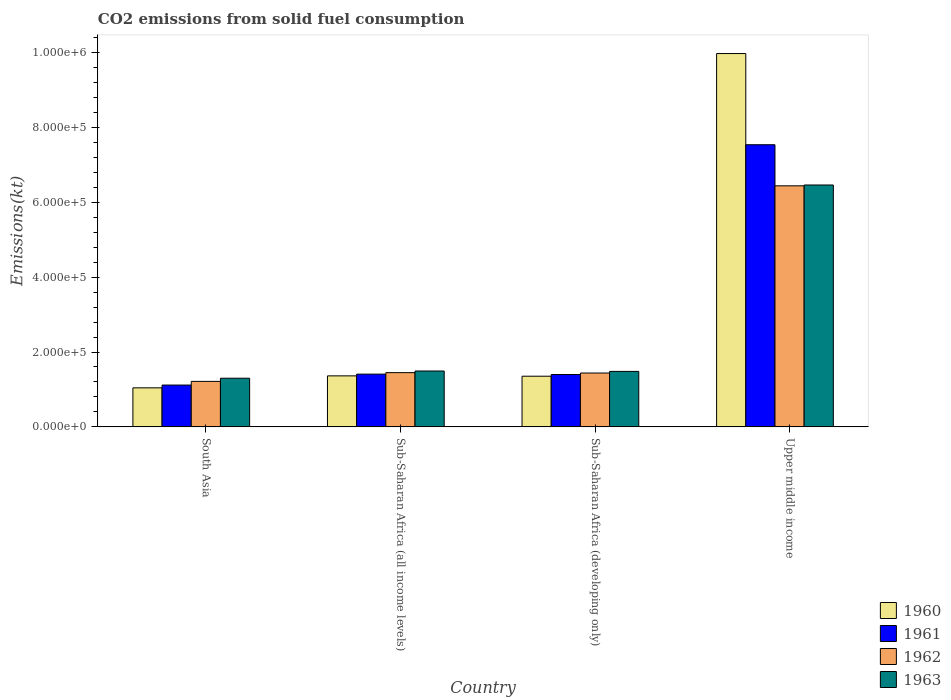Are the number of bars per tick equal to the number of legend labels?
Your answer should be compact. Yes. Are the number of bars on each tick of the X-axis equal?
Ensure brevity in your answer.  Yes. What is the label of the 3rd group of bars from the left?
Your response must be concise. Sub-Saharan Africa (developing only). What is the amount of CO2 emitted in 1962 in Sub-Saharan Africa (all income levels)?
Provide a short and direct response. 1.45e+05. Across all countries, what is the maximum amount of CO2 emitted in 1962?
Ensure brevity in your answer.  6.44e+05. Across all countries, what is the minimum amount of CO2 emitted in 1963?
Provide a short and direct response. 1.30e+05. In which country was the amount of CO2 emitted in 1960 maximum?
Make the answer very short. Upper middle income. In which country was the amount of CO2 emitted in 1962 minimum?
Your answer should be very brief. South Asia. What is the total amount of CO2 emitted in 1962 in the graph?
Your answer should be very brief. 1.05e+06. What is the difference between the amount of CO2 emitted in 1961 in South Asia and that in Sub-Saharan Africa (developing only)?
Offer a very short reply. -2.82e+04. What is the difference between the amount of CO2 emitted in 1962 in Upper middle income and the amount of CO2 emitted in 1960 in Sub-Saharan Africa (developing only)?
Make the answer very short. 5.09e+05. What is the average amount of CO2 emitted in 1963 per country?
Your answer should be very brief. 2.68e+05. What is the difference between the amount of CO2 emitted of/in 1960 and amount of CO2 emitted of/in 1962 in Sub-Saharan Africa (developing only)?
Keep it short and to the point. -8539.18. What is the ratio of the amount of CO2 emitted in 1960 in South Asia to that in Sub-Saharan Africa (developing only)?
Provide a short and direct response. 0.77. Is the amount of CO2 emitted in 1962 in Sub-Saharan Africa (all income levels) less than that in Sub-Saharan Africa (developing only)?
Give a very brief answer. No. What is the difference between the highest and the second highest amount of CO2 emitted in 1960?
Ensure brevity in your answer.  8.61e+05. What is the difference between the highest and the lowest amount of CO2 emitted in 1960?
Make the answer very short. 8.93e+05. Is the sum of the amount of CO2 emitted in 1963 in South Asia and Sub-Saharan Africa (all income levels) greater than the maximum amount of CO2 emitted in 1961 across all countries?
Your answer should be very brief. No. Is it the case that in every country, the sum of the amount of CO2 emitted in 1961 and amount of CO2 emitted in 1963 is greater than the sum of amount of CO2 emitted in 1962 and amount of CO2 emitted in 1960?
Your answer should be very brief. No. Is it the case that in every country, the sum of the amount of CO2 emitted in 1961 and amount of CO2 emitted in 1960 is greater than the amount of CO2 emitted in 1963?
Give a very brief answer. Yes. Are the values on the major ticks of Y-axis written in scientific E-notation?
Your response must be concise. Yes. Does the graph contain grids?
Offer a very short reply. No. Where does the legend appear in the graph?
Ensure brevity in your answer.  Bottom right. How are the legend labels stacked?
Offer a terse response. Vertical. What is the title of the graph?
Offer a very short reply. CO2 emissions from solid fuel consumption. What is the label or title of the Y-axis?
Offer a very short reply. Emissions(kt). What is the Emissions(kt) of 1960 in South Asia?
Provide a short and direct response. 1.04e+05. What is the Emissions(kt) of 1961 in South Asia?
Provide a short and direct response. 1.12e+05. What is the Emissions(kt) in 1962 in South Asia?
Ensure brevity in your answer.  1.22e+05. What is the Emissions(kt) in 1963 in South Asia?
Provide a succinct answer. 1.30e+05. What is the Emissions(kt) of 1960 in Sub-Saharan Africa (all income levels)?
Ensure brevity in your answer.  1.36e+05. What is the Emissions(kt) in 1961 in Sub-Saharan Africa (all income levels)?
Your answer should be compact. 1.41e+05. What is the Emissions(kt) in 1962 in Sub-Saharan Africa (all income levels)?
Offer a very short reply. 1.45e+05. What is the Emissions(kt) of 1963 in Sub-Saharan Africa (all income levels)?
Give a very brief answer. 1.49e+05. What is the Emissions(kt) in 1960 in Sub-Saharan Africa (developing only)?
Ensure brevity in your answer.  1.35e+05. What is the Emissions(kt) of 1961 in Sub-Saharan Africa (developing only)?
Ensure brevity in your answer.  1.40e+05. What is the Emissions(kt) of 1962 in Sub-Saharan Africa (developing only)?
Provide a succinct answer. 1.44e+05. What is the Emissions(kt) in 1963 in Sub-Saharan Africa (developing only)?
Your response must be concise. 1.48e+05. What is the Emissions(kt) of 1960 in Upper middle income?
Your answer should be compact. 9.97e+05. What is the Emissions(kt) of 1961 in Upper middle income?
Offer a terse response. 7.54e+05. What is the Emissions(kt) of 1962 in Upper middle income?
Give a very brief answer. 6.44e+05. What is the Emissions(kt) in 1963 in Upper middle income?
Provide a short and direct response. 6.46e+05. Across all countries, what is the maximum Emissions(kt) of 1960?
Ensure brevity in your answer.  9.97e+05. Across all countries, what is the maximum Emissions(kt) in 1961?
Provide a short and direct response. 7.54e+05. Across all countries, what is the maximum Emissions(kt) of 1962?
Provide a short and direct response. 6.44e+05. Across all countries, what is the maximum Emissions(kt) in 1963?
Keep it short and to the point. 6.46e+05. Across all countries, what is the minimum Emissions(kt) in 1960?
Make the answer very short. 1.04e+05. Across all countries, what is the minimum Emissions(kt) in 1961?
Provide a succinct answer. 1.12e+05. Across all countries, what is the minimum Emissions(kt) of 1962?
Offer a very short reply. 1.22e+05. Across all countries, what is the minimum Emissions(kt) in 1963?
Keep it short and to the point. 1.30e+05. What is the total Emissions(kt) of 1960 in the graph?
Your answer should be very brief. 1.37e+06. What is the total Emissions(kt) in 1961 in the graph?
Provide a succinct answer. 1.15e+06. What is the total Emissions(kt) in 1962 in the graph?
Provide a succinct answer. 1.05e+06. What is the total Emissions(kt) of 1963 in the graph?
Offer a terse response. 1.07e+06. What is the difference between the Emissions(kt) in 1960 in South Asia and that in Sub-Saharan Africa (all income levels)?
Ensure brevity in your answer.  -3.20e+04. What is the difference between the Emissions(kt) of 1961 in South Asia and that in Sub-Saharan Africa (all income levels)?
Offer a very short reply. -2.92e+04. What is the difference between the Emissions(kt) in 1962 in South Asia and that in Sub-Saharan Africa (all income levels)?
Your answer should be very brief. -2.33e+04. What is the difference between the Emissions(kt) in 1963 in South Asia and that in Sub-Saharan Africa (all income levels)?
Give a very brief answer. -1.93e+04. What is the difference between the Emissions(kt) in 1960 in South Asia and that in Sub-Saharan Africa (developing only)?
Give a very brief answer. -3.10e+04. What is the difference between the Emissions(kt) of 1961 in South Asia and that in Sub-Saharan Africa (developing only)?
Make the answer very short. -2.82e+04. What is the difference between the Emissions(kt) in 1962 in South Asia and that in Sub-Saharan Africa (developing only)?
Make the answer very short. -2.23e+04. What is the difference between the Emissions(kt) of 1963 in South Asia and that in Sub-Saharan Africa (developing only)?
Your answer should be compact. -1.82e+04. What is the difference between the Emissions(kt) in 1960 in South Asia and that in Upper middle income?
Make the answer very short. -8.93e+05. What is the difference between the Emissions(kt) in 1961 in South Asia and that in Upper middle income?
Your answer should be very brief. -6.42e+05. What is the difference between the Emissions(kt) of 1962 in South Asia and that in Upper middle income?
Your response must be concise. -5.22e+05. What is the difference between the Emissions(kt) in 1963 in South Asia and that in Upper middle income?
Give a very brief answer. -5.16e+05. What is the difference between the Emissions(kt) of 1960 in Sub-Saharan Africa (all income levels) and that in Sub-Saharan Africa (developing only)?
Provide a short and direct response. 947.7. What is the difference between the Emissions(kt) of 1961 in Sub-Saharan Africa (all income levels) and that in Sub-Saharan Africa (developing only)?
Your response must be concise. 979.79. What is the difference between the Emissions(kt) in 1962 in Sub-Saharan Africa (all income levels) and that in Sub-Saharan Africa (developing only)?
Give a very brief answer. 1007.5. What is the difference between the Emissions(kt) in 1963 in Sub-Saharan Africa (all income levels) and that in Sub-Saharan Africa (developing only)?
Your answer should be very brief. 1037.94. What is the difference between the Emissions(kt) of 1960 in Sub-Saharan Africa (all income levels) and that in Upper middle income?
Offer a terse response. -8.61e+05. What is the difference between the Emissions(kt) of 1961 in Sub-Saharan Africa (all income levels) and that in Upper middle income?
Make the answer very short. -6.13e+05. What is the difference between the Emissions(kt) in 1962 in Sub-Saharan Africa (all income levels) and that in Upper middle income?
Your answer should be very brief. -4.99e+05. What is the difference between the Emissions(kt) of 1963 in Sub-Saharan Africa (all income levels) and that in Upper middle income?
Offer a very short reply. -4.97e+05. What is the difference between the Emissions(kt) in 1960 in Sub-Saharan Africa (developing only) and that in Upper middle income?
Provide a short and direct response. -8.62e+05. What is the difference between the Emissions(kt) of 1961 in Sub-Saharan Africa (developing only) and that in Upper middle income?
Give a very brief answer. -6.14e+05. What is the difference between the Emissions(kt) in 1962 in Sub-Saharan Africa (developing only) and that in Upper middle income?
Your response must be concise. -5.00e+05. What is the difference between the Emissions(kt) of 1963 in Sub-Saharan Africa (developing only) and that in Upper middle income?
Offer a terse response. -4.98e+05. What is the difference between the Emissions(kt) of 1960 in South Asia and the Emissions(kt) of 1961 in Sub-Saharan Africa (all income levels)?
Your response must be concise. -3.66e+04. What is the difference between the Emissions(kt) in 1960 in South Asia and the Emissions(kt) in 1962 in Sub-Saharan Africa (all income levels)?
Provide a succinct answer. -4.06e+04. What is the difference between the Emissions(kt) of 1960 in South Asia and the Emissions(kt) of 1963 in Sub-Saharan Africa (all income levels)?
Give a very brief answer. -4.49e+04. What is the difference between the Emissions(kt) of 1961 in South Asia and the Emissions(kt) of 1962 in Sub-Saharan Africa (all income levels)?
Give a very brief answer. -3.31e+04. What is the difference between the Emissions(kt) of 1961 in South Asia and the Emissions(kt) of 1963 in Sub-Saharan Africa (all income levels)?
Your answer should be very brief. -3.75e+04. What is the difference between the Emissions(kt) in 1962 in South Asia and the Emissions(kt) in 1963 in Sub-Saharan Africa (all income levels)?
Offer a terse response. -2.77e+04. What is the difference between the Emissions(kt) in 1960 in South Asia and the Emissions(kt) in 1961 in Sub-Saharan Africa (developing only)?
Give a very brief answer. -3.56e+04. What is the difference between the Emissions(kt) in 1960 in South Asia and the Emissions(kt) in 1962 in Sub-Saharan Africa (developing only)?
Your answer should be compact. -3.96e+04. What is the difference between the Emissions(kt) of 1960 in South Asia and the Emissions(kt) of 1963 in Sub-Saharan Africa (developing only)?
Offer a very short reply. -4.39e+04. What is the difference between the Emissions(kt) in 1961 in South Asia and the Emissions(kt) in 1962 in Sub-Saharan Africa (developing only)?
Keep it short and to the point. -3.21e+04. What is the difference between the Emissions(kt) of 1961 in South Asia and the Emissions(kt) of 1963 in Sub-Saharan Africa (developing only)?
Provide a succinct answer. -3.65e+04. What is the difference between the Emissions(kt) in 1962 in South Asia and the Emissions(kt) in 1963 in Sub-Saharan Africa (developing only)?
Your answer should be compact. -2.67e+04. What is the difference between the Emissions(kt) of 1960 in South Asia and the Emissions(kt) of 1961 in Upper middle income?
Keep it short and to the point. -6.49e+05. What is the difference between the Emissions(kt) in 1960 in South Asia and the Emissions(kt) in 1962 in Upper middle income?
Keep it short and to the point. -5.40e+05. What is the difference between the Emissions(kt) in 1960 in South Asia and the Emissions(kt) in 1963 in Upper middle income?
Ensure brevity in your answer.  -5.42e+05. What is the difference between the Emissions(kt) in 1961 in South Asia and the Emissions(kt) in 1962 in Upper middle income?
Provide a succinct answer. -5.32e+05. What is the difference between the Emissions(kt) in 1961 in South Asia and the Emissions(kt) in 1963 in Upper middle income?
Provide a short and direct response. -5.34e+05. What is the difference between the Emissions(kt) in 1962 in South Asia and the Emissions(kt) in 1963 in Upper middle income?
Offer a very short reply. -5.25e+05. What is the difference between the Emissions(kt) in 1960 in Sub-Saharan Africa (all income levels) and the Emissions(kt) in 1961 in Sub-Saharan Africa (developing only)?
Make the answer very short. -3634.8. What is the difference between the Emissions(kt) in 1960 in Sub-Saharan Africa (all income levels) and the Emissions(kt) in 1962 in Sub-Saharan Africa (developing only)?
Keep it short and to the point. -7591.49. What is the difference between the Emissions(kt) in 1960 in Sub-Saharan Africa (all income levels) and the Emissions(kt) in 1963 in Sub-Saharan Africa (developing only)?
Your answer should be very brief. -1.19e+04. What is the difference between the Emissions(kt) of 1961 in Sub-Saharan Africa (all income levels) and the Emissions(kt) of 1962 in Sub-Saharan Africa (developing only)?
Ensure brevity in your answer.  -2976.9. What is the difference between the Emissions(kt) in 1961 in Sub-Saharan Africa (all income levels) and the Emissions(kt) in 1963 in Sub-Saharan Africa (developing only)?
Provide a short and direct response. -7322.24. What is the difference between the Emissions(kt) in 1962 in Sub-Saharan Africa (all income levels) and the Emissions(kt) in 1963 in Sub-Saharan Africa (developing only)?
Offer a very short reply. -3337.84. What is the difference between the Emissions(kt) of 1960 in Sub-Saharan Africa (all income levels) and the Emissions(kt) of 1961 in Upper middle income?
Ensure brevity in your answer.  -6.17e+05. What is the difference between the Emissions(kt) of 1960 in Sub-Saharan Africa (all income levels) and the Emissions(kt) of 1962 in Upper middle income?
Provide a succinct answer. -5.08e+05. What is the difference between the Emissions(kt) of 1960 in Sub-Saharan Africa (all income levels) and the Emissions(kt) of 1963 in Upper middle income?
Your answer should be compact. -5.10e+05. What is the difference between the Emissions(kt) of 1961 in Sub-Saharan Africa (all income levels) and the Emissions(kt) of 1962 in Upper middle income?
Ensure brevity in your answer.  -5.03e+05. What is the difference between the Emissions(kt) in 1961 in Sub-Saharan Africa (all income levels) and the Emissions(kt) in 1963 in Upper middle income?
Give a very brief answer. -5.05e+05. What is the difference between the Emissions(kt) of 1962 in Sub-Saharan Africa (all income levels) and the Emissions(kt) of 1963 in Upper middle income?
Your response must be concise. -5.01e+05. What is the difference between the Emissions(kt) of 1960 in Sub-Saharan Africa (developing only) and the Emissions(kt) of 1961 in Upper middle income?
Provide a succinct answer. -6.18e+05. What is the difference between the Emissions(kt) in 1960 in Sub-Saharan Africa (developing only) and the Emissions(kt) in 1962 in Upper middle income?
Offer a terse response. -5.09e+05. What is the difference between the Emissions(kt) of 1960 in Sub-Saharan Africa (developing only) and the Emissions(kt) of 1963 in Upper middle income?
Offer a very short reply. -5.11e+05. What is the difference between the Emissions(kt) in 1961 in Sub-Saharan Africa (developing only) and the Emissions(kt) in 1962 in Upper middle income?
Your answer should be very brief. -5.04e+05. What is the difference between the Emissions(kt) in 1961 in Sub-Saharan Africa (developing only) and the Emissions(kt) in 1963 in Upper middle income?
Keep it short and to the point. -5.06e+05. What is the difference between the Emissions(kt) in 1962 in Sub-Saharan Africa (developing only) and the Emissions(kt) in 1963 in Upper middle income?
Your response must be concise. -5.02e+05. What is the average Emissions(kt) in 1960 per country?
Ensure brevity in your answer.  3.43e+05. What is the average Emissions(kt) of 1961 per country?
Provide a succinct answer. 2.87e+05. What is the average Emissions(kt) in 1962 per country?
Your response must be concise. 2.64e+05. What is the average Emissions(kt) in 1963 per country?
Your response must be concise. 2.68e+05. What is the difference between the Emissions(kt) in 1960 and Emissions(kt) in 1961 in South Asia?
Your answer should be compact. -7419.38. What is the difference between the Emissions(kt) of 1960 and Emissions(kt) of 1962 in South Asia?
Provide a succinct answer. -1.72e+04. What is the difference between the Emissions(kt) in 1960 and Emissions(kt) in 1963 in South Asia?
Your answer should be very brief. -2.57e+04. What is the difference between the Emissions(kt) in 1961 and Emissions(kt) in 1962 in South Asia?
Ensure brevity in your answer.  -9815.22. What is the difference between the Emissions(kt) in 1961 and Emissions(kt) in 1963 in South Asia?
Provide a succinct answer. -1.82e+04. What is the difference between the Emissions(kt) in 1962 and Emissions(kt) in 1963 in South Asia?
Provide a succinct answer. -8416.72. What is the difference between the Emissions(kt) in 1960 and Emissions(kt) in 1961 in Sub-Saharan Africa (all income levels)?
Ensure brevity in your answer.  -4614.59. What is the difference between the Emissions(kt) of 1960 and Emissions(kt) of 1962 in Sub-Saharan Africa (all income levels)?
Your answer should be compact. -8598.99. What is the difference between the Emissions(kt) in 1960 and Emissions(kt) in 1963 in Sub-Saharan Africa (all income levels)?
Offer a terse response. -1.30e+04. What is the difference between the Emissions(kt) of 1961 and Emissions(kt) of 1962 in Sub-Saharan Africa (all income levels)?
Your response must be concise. -3984.4. What is the difference between the Emissions(kt) in 1961 and Emissions(kt) in 1963 in Sub-Saharan Africa (all income levels)?
Offer a terse response. -8360.18. What is the difference between the Emissions(kt) in 1962 and Emissions(kt) in 1963 in Sub-Saharan Africa (all income levels)?
Make the answer very short. -4375.77. What is the difference between the Emissions(kt) of 1960 and Emissions(kt) of 1961 in Sub-Saharan Africa (developing only)?
Your answer should be compact. -4582.5. What is the difference between the Emissions(kt) in 1960 and Emissions(kt) in 1962 in Sub-Saharan Africa (developing only)?
Give a very brief answer. -8539.18. What is the difference between the Emissions(kt) of 1960 and Emissions(kt) of 1963 in Sub-Saharan Africa (developing only)?
Offer a very short reply. -1.29e+04. What is the difference between the Emissions(kt) in 1961 and Emissions(kt) in 1962 in Sub-Saharan Africa (developing only)?
Ensure brevity in your answer.  -3956.69. What is the difference between the Emissions(kt) in 1961 and Emissions(kt) in 1963 in Sub-Saharan Africa (developing only)?
Ensure brevity in your answer.  -8302.03. What is the difference between the Emissions(kt) in 1962 and Emissions(kt) in 1963 in Sub-Saharan Africa (developing only)?
Your answer should be compact. -4345.34. What is the difference between the Emissions(kt) of 1960 and Emissions(kt) of 1961 in Upper middle income?
Make the answer very short. 2.44e+05. What is the difference between the Emissions(kt) of 1960 and Emissions(kt) of 1962 in Upper middle income?
Provide a short and direct response. 3.53e+05. What is the difference between the Emissions(kt) in 1960 and Emissions(kt) in 1963 in Upper middle income?
Give a very brief answer. 3.51e+05. What is the difference between the Emissions(kt) in 1961 and Emissions(kt) in 1962 in Upper middle income?
Offer a very short reply. 1.10e+05. What is the difference between the Emissions(kt) of 1961 and Emissions(kt) of 1963 in Upper middle income?
Give a very brief answer. 1.08e+05. What is the difference between the Emissions(kt) of 1962 and Emissions(kt) of 1963 in Upper middle income?
Ensure brevity in your answer.  -2192.22. What is the ratio of the Emissions(kt) of 1960 in South Asia to that in Sub-Saharan Africa (all income levels)?
Offer a terse response. 0.77. What is the ratio of the Emissions(kt) of 1961 in South Asia to that in Sub-Saharan Africa (all income levels)?
Provide a short and direct response. 0.79. What is the ratio of the Emissions(kt) in 1962 in South Asia to that in Sub-Saharan Africa (all income levels)?
Your answer should be compact. 0.84. What is the ratio of the Emissions(kt) of 1963 in South Asia to that in Sub-Saharan Africa (all income levels)?
Keep it short and to the point. 0.87. What is the ratio of the Emissions(kt) in 1960 in South Asia to that in Sub-Saharan Africa (developing only)?
Give a very brief answer. 0.77. What is the ratio of the Emissions(kt) of 1961 in South Asia to that in Sub-Saharan Africa (developing only)?
Your answer should be compact. 0.8. What is the ratio of the Emissions(kt) in 1962 in South Asia to that in Sub-Saharan Africa (developing only)?
Your answer should be very brief. 0.84. What is the ratio of the Emissions(kt) in 1963 in South Asia to that in Sub-Saharan Africa (developing only)?
Keep it short and to the point. 0.88. What is the ratio of the Emissions(kt) of 1960 in South Asia to that in Upper middle income?
Offer a very short reply. 0.1. What is the ratio of the Emissions(kt) in 1961 in South Asia to that in Upper middle income?
Provide a short and direct response. 0.15. What is the ratio of the Emissions(kt) in 1962 in South Asia to that in Upper middle income?
Your answer should be very brief. 0.19. What is the ratio of the Emissions(kt) of 1963 in South Asia to that in Upper middle income?
Your answer should be compact. 0.2. What is the ratio of the Emissions(kt) in 1960 in Sub-Saharan Africa (all income levels) to that in Sub-Saharan Africa (developing only)?
Offer a terse response. 1.01. What is the ratio of the Emissions(kt) of 1961 in Sub-Saharan Africa (all income levels) to that in Sub-Saharan Africa (developing only)?
Keep it short and to the point. 1.01. What is the ratio of the Emissions(kt) of 1960 in Sub-Saharan Africa (all income levels) to that in Upper middle income?
Provide a succinct answer. 0.14. What is the ratio of the Emissions(kt) in 1961 in Sub-Saharan Africa (all income levels) to that in Upper middle income?
Provide a short and direct response. 0.19. What is the ratio of the Emissions(kt) in 1962 in Sub-Saharan Africa (all income levels) to that in Upper middle income?
Ensure brevity in your answer.  0.23. What is the ratio of the Emissions(kt) in 1963 in Sub-Saharan Africa (all income levels) to that in Upper middle income?
Offer a terse response. 0.23. What is the ratio of the Emissions(kt) of 1960 in Sub-Saharan Africa (developing only) to that in Upper middle income?
Your response must be concise. 0.14. What is the ratio of the Emissions(kt) of 1961 in Sub-Saharan Africa (developing only) to that in Upper middle income?
Give a very brief answer. 0.19. What is the ratio of the Emissions(kt) in 1962 in Sub-Saharan Africa (developing only) to that in Upper middle income?
Provide a succinct answer. 0.22. What is the ratio of the Emissions(kt) of 1963 in Sub-Saharan Africa (developing only) to that in Upper middle income?
Ensure brevity in your answer.  0.23. What is the difference between the highest and the second highest Emissions(kt) of 1960?
Make the answer very short. 8.61e+05. What is the difference between the highest and the second highest Emissions(kt) in 1961?
Offer a terse response. 6.13e+05. What is the difference between the highest and the second highest Emissions(kt) of 1962?
Keep it short and to the point. 4.99e+05. What is the difference between the highest and the second highest Emissions(kt) of 1963?
Offer a terse response. 4.97e+05. What is the difference between the highest and the lowest Emissions(kt) of 1960?
Offer a terse response. 8.93e+05. What is the difference between the highest and the lowest Emissions(kt) of 1961?
Provide a succinct answer. 6.42e+05. What is the difference between the highest and the lowest Emissions(kt) of 1962?
Offer a very short reply. 5.22e+05. What is the difference between the highest and the lowest Emissions(kt) in 1963?
Provide a succinct answer. 5.16e+05. 